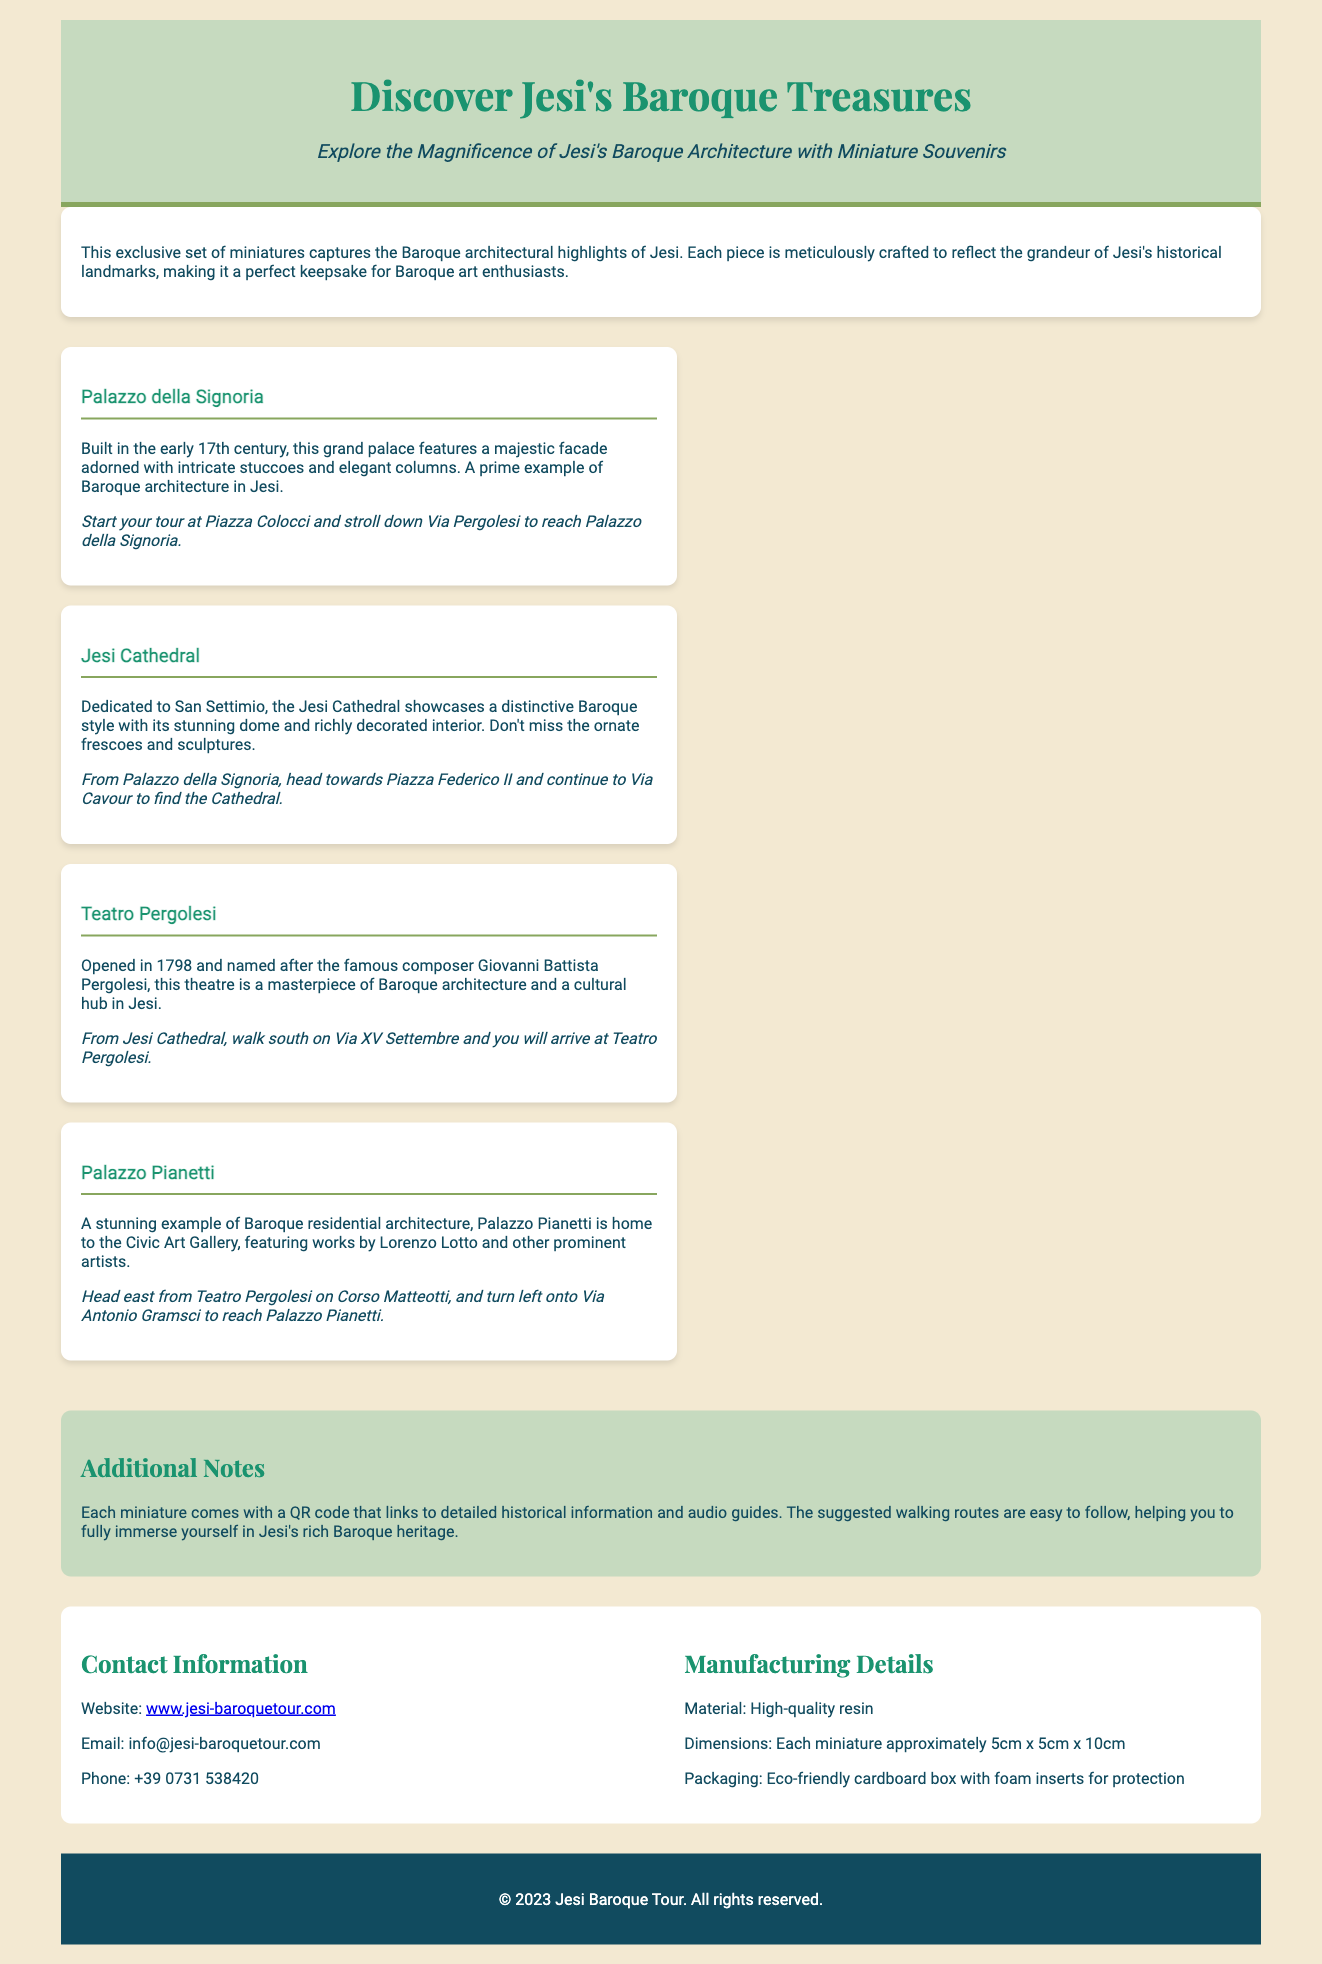What is the title of the product? The title of the product is presented at the top of the document in a prominent heading.
Answer: Discover Jesi's Baroque Treasures How many miniatures are included in the set? The document describes four distinct miniatures representing Baroque architectural highlights in Jesi.
Answer: Four What is the suggested starting point for the walking tour to Palazzo della Signoria? The document provides a specific location to begin the walking tour to Palazzo della Signoria.
Answer: Piazza Colocci What material are the miniatures made from? The manufacturing details section specifies the material used for the miniatures.
Answer: High-quality resin Who is the theatre named after? The description of Teatro Pergolesi includes the name of the famous composer associated with it.
Answer: Giovanni Battista Pergolesi What unique feature is included with each miniature? Additional notes highlight a feature included with the miniatures to enhance the experience.
Answer: QR code What is the email contact provided for inquiries? The contact information section includes the email address for customer inquiries.
Answer: info@jesi-baroquetour.com What color is the footer background? The footer is described in the document, including its color.
Answer: #114b5f 